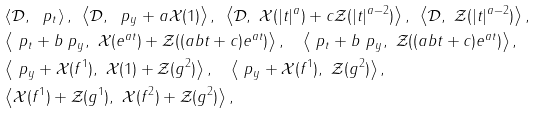Convert formula to latex. <formula><loc_0><loc_0><loc_500><loc_500>& \left \langle \mathcal { D } , \ \ p _ { t } \right \rangle , \, \ \left \langle \mathcal { D } , \ \ p _ { y } + a \mathcal { X } ( 1 ) \right \rangle , \, \ \left \langle \mathcal { D } , \ \mathcal { X } ( | t | ^ { a } ) + c \mathcal { Z } ( | t | ^ { a - 2 } ) \right \rangle , \, \ \left \langle \mathcal { D } , \ \mathcal { Z } ( | t | ^ { a - 2 } ) \right \rangle , \\ & \left \langle \ p _ { t } + b \ p _ { y } , \ \mathcal { X } ( e ^ { a t } ) + \mathcal { Z } ( ( a b t + c ) e ^ { a t } ) \right \rangle , \quad \left \langle \ p _ { t } + b \ p _ { y } , \ \mathcal { Z } ( ( a b t + c ) e ^ { a t } ) \right \rangle , \\ & \left \langle \ p _ { y } + \mathcal { X } ( f ^ { 1 } ) , \ \mathcal { X } ( 1 ) + \mathcal { Z } ( g ^ { 2 } ) \right \rangle , \quad \left \langle \ p _ { y } + \mathcal { X } ( f ^ { 1 } ) , \ \mathcal { Z } ( g ^ { 2 } ) \right \rangle , \\ & \left \langle \mathcal { X } ( f ^ { 1 } ) + \mathcal { Z } ( g ^ { 1 } ) , \ \mathcal { X } ( f ^ { 2 } ) + \mathcal { Z } ( g ^ { 2 } ) \right \rangle ,</formula> 